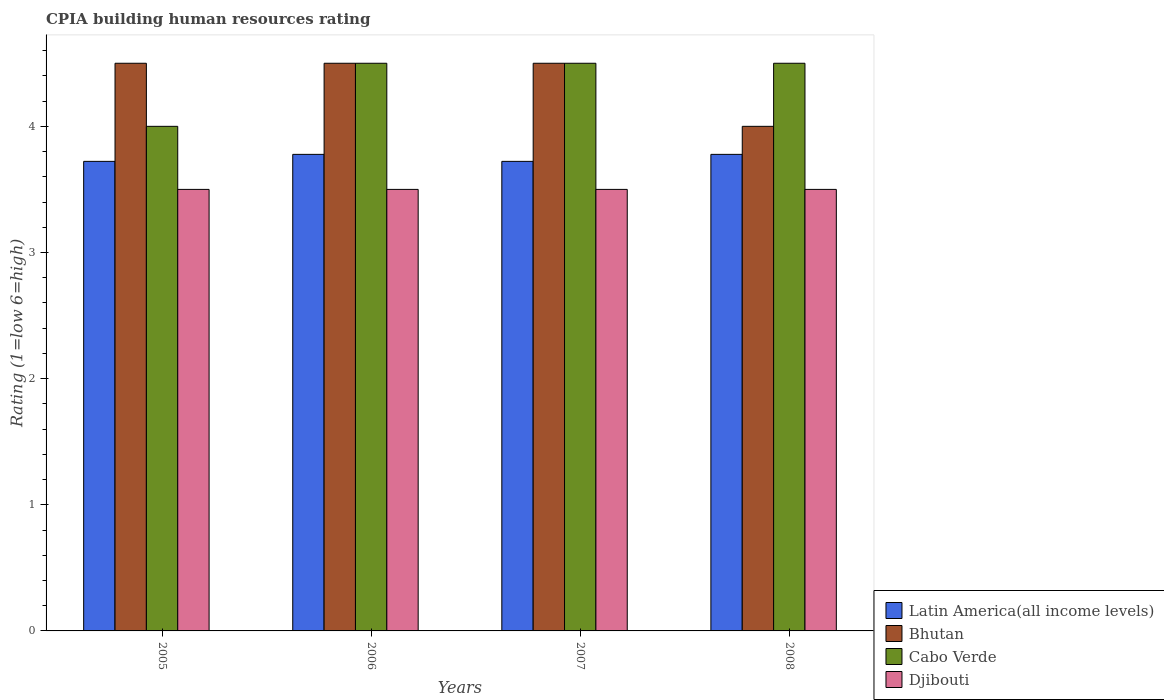Are the number of bars per tick equal to the number of legend labels?
Ensure brevity in your answer.  Yes. Are the number of bars on each tick of the X-axis equal?
Your answer should be very brief. Yes. How many bars are there on the 1st tick from the left?
Give a very brief answer. 4. How many bars are there on the 1st tick from the right?
Keep it short and to the point. 4. What is the label of the 4th group of bars from the left?
Offer a terse response. 2008. What is the CPIA rating in Latin America(all income levels) in 2007?
Ensure brevity in your answer.  3.72. Across all years, what is the maximum CPIA rating in Bhutan?
Keep it short and to the point. 4.5. Across all years, what is the minimum CPIA rating in Latin America(all income levels)?
Offer a terse response. 3.72. In which year was the CPIA rating in Bhutan maximum?
Ensure brevity in your answer.  2005. In which year was the CPIA rating in Cabo Verde minimum?
Offer a terse response. 2005. What is the total CPIA rating in Djibouti in the graph?
Provide a succinct answer. 14. In the year 2005, what is the difference between the CPIA rating in Latin America(all income levels) and CPIA rating in Cabo Verde?
Offer a terse response. -0.28. In how many years, is the CPIA rating in Latin America(all income levels) greater than 0.8?
Your response must be concise. 4. What is the ratio of the CPIA rating in Djibouti in 2006 to that in 2008?
Your answer should be very brief. 1. Is the CPIA rating in Djibouti in 2006 less than that in 2007?
Provide a short and direct response. No. Is the difference between the CPIA rating in Latin America(all income levels) in 2005 and 2006 greater than the difference between the CPIA rating in Cabo Verde in 2005 and 2006?
Ensure brevity in your answer.  Yes. What is the difference between the highest and the second highest CPIA rating in Bhutan?
Make the answer very short. 0. What is the difference between the highest and the lowest CPIA rating in Latin America(all income levels)?
Make the answer very short. 0.06. What does the 4th bar from the left in 2007 represents?
Give a very brief answer. Djibouti. What does the 4th bar from the right in 2008 represents?
Offer a terse response. Latin America(all income levels). Are all the bars in the graph horizontal?
Keep it short and to the point. No. Does the graph contain any zero values?
Give a very brief answer. No. How many legend labels are there?
Provide a succinct answer. 4. What is the title of the graph?
Keep it short and to the point. CPIA building human resources rating. Does "Italy" appear as one of the legend labels in the graph?
Give a very brief answer. No. What is the label or title of the X-axis?
Your answer should be compact. Years. What is the label or title of the Y-axis?
Keep it short and to the point. Rating (1=low 6=high). What is the Rating (1=low 6=high) of Latin America(all income levels) in 2005?
Your answer should be very brief. 3.72. What is the Rating (1=low 6=high) in Cabo Verde in 2005?
Your response must be concise. 4. What is the Rating (1=low 6=high) of Djibouti in 2005?
Your answer should be compact. 3.5. What is the Rating (1=low 6=high) of Latin America(all income levels) in 2006?
Provide a succinct answer. 3.78. What is the Rating (1=low 6=high) of Bhutan in 2006?
Keep it short and to the point. 4.5. What is the Rating (1=low 6=high) of Djibouti in 2006?
Offer a terse response. 3.5. What is the Rating (1=low 6=high) in Latin America(all income levels) in 2007?
Ensure brevity in your answer.  3.72. What is the Rating (1=low 6=high) of Cabo Verde in 2007?
Your answer should be compact. 4.5. What is the Rating (1=low 6=high) of Djibouti in 2007?
Keep it short and to the point. 3.5. What is the Rating (1=low 6=high) in Latin America(all income levels) in 2008?
Give a very brief answer. 3.78. What is the Rating (1=low 6=high) of Bhutan in 2008?
Keep it short and to the point. 4. What is the Rating (1=low 6=high) in Djibouti in 2008?
Ensure brevity in your answer.  3.5. Across all years, what is the maximum Rating (1=low 6=high) of Latin America(all income levels)?
Your answer should be very brief. 3.78. Across all years, what is the maximum Rating (1=low 6=high) in Djibouti?
Offer a very short reply. 3.5. Across all years, what is the minimum Rating (1=low 6=high) of Latin America(all income levels)?
Make the answer very short. 3.72. Across all years, what is the minimum Rating (1=low 6=high) in Bhutan?
Provide a short and direct response. 4. Across all years, what is the minimum Rating (1=low 6=high) of Cabo Verde?
Give a very brief answer. 4. Across all years, what is the minimum Rating (1=low 6=high) in Djibouti?
Keep it short and to the point. 3.5. What is the total Rating (1=low 6=high) of Latin America(all income levels) in the graph?
Give a very brief answer. 15. What is the total Rating (1=low 6=high) of Cabo Verde in the graph?
Offer a terse response. 17.5. What is the total Rating (1=low 6=high) of Djibouti in the graph?
Keep it short and to the point. 14. What is the difference between the Rating (1=low 6=high) in Latin America(all income levels) in 2005 and that in 2006?
Your answer should be compact. -0.06. What is the difference between the Rating (1=low 6=high) in Bhutan in 2005 and that in 2006?
Provide a succinct answer. 0. What is the difference between the Rating (1=low 6=high) of Cabo Verde in 2005 and that in 2006?
Give a very brief answer. -0.5. What is the difference between the Rating (1=low 6=high) of Latin America(all income levels) in 2005 and that in 2007?
Ensure brevity in your answer.  0. What is the difference between the Rating (1=low 6=high) of Bhutan in 2005 and that in 2007?
Offer a very short reply. 0. What is the difference between the Rating (1=low 6=high) in Latin America(all income levels) in 2005 and that in 2008?
Your answer should be very brief. -0.06. What is the difference between the Rating (1=low 6=high) of Bhutan in 2005 and that in 2008?
Ensure brevity in your answer.  0.5. What is the difference between the Rating (1=low 6=high) of Cabo Verde in 2005 and that in 2008?
Keep it short and to the point. -0.5. What is the difference between the Rating (1=low 6=high) in Djibouti in 2005 and that in 2008?
Your answer should be compact. 0. What is the difference between the Rating (1=low 6=high) in Latin America(all income levels) in 2006 and that in 2007?
Keep it short and to the point. 0.06. What is the difference between the Rating (1=low 6=high) of Cabo Verde in 2006 and that in 2007?
Provide a succinct answer. 0. What is the difference between the Rating (1=low 6=high) in Djibouti in 2006 and that in 2007?
Provide a succinct answer. 0. What is the difference between the Rating (1=low 6=high) of Latin America(all income levels) in 2006 and that in 2008?
Ensure brevity in your answer.  0. What is the difference between the Rating (1=low 6=high) in Bhutan in 2006 and that in 2008?
Offer a very short reply. 0.5. What is the difference between the Rating (1=low 6=high) in Djibouti in 2006 and that in 2008?
Provide a succinct answer. 0. What is the difference between the Rating (1=low 6=high) of Latin America(all income levels) in 2007 and that in 2008?
Offer a very short reply. -0.06. What is the difference between the Rating (1=low 6=high) in Bhutan in 2007 and that in 2008?
Your answer should be compact. 0.5. What is the difference between the Rating (1=low 6=high) of Cabo Verde in 2007 and that in 2008?
Provide a succinct answer. 0. What is the difference between the Rating (1=low 6=high) in Djibouti in 2007 and that in 2008?
Ensure brevity in your answer.  0. What is the difference between the Rating (1=low 6=high) in Latin America(all income levels) in 2005 and the Rating (1=low 6=high) in Bhutan in 2006?
Offer a terse response. -0.78. What is the difference between the Rating (1=low 6=high) of Latin America(all income levels) in 2005 and the Rating (1=low 6=high) of Cabo Verde in 2006?
Offer a very short reply. -0.78. What is the difference between the Rating (1=low 6=high) of Latin America(all income levels) in 2005 and the Rating (1=low 6=high) of Djibouti in 2006?
Your response must be concise. 0.22. What is the difference between the Rating (1=low 6=high) of Latin America(all income levels) in 2005 and the Rating (1=low 6=high) of Bhutan in 2007?
Offer a very short reply. -0.78. What is the difference between the Rating (1=low 6=high) in Latin America(all income levels) in 2005 and the Rating (1=low 6=high) in Cabo Verde in 2007?
Keep it short and to the point. -0.78. What is the difference between the Rating (1=low 6=high) of Latin America(all income levels) in 2005 and the Rating (1=low 6=high) of Djibouti in 2007?
Offer a terse response. 0.22. What is the difference between the Rating (1=low 6=high) in Cabo Verde in 2005 and the Rating (1=low 6=high) in Djibouti in 2007?
Offer a very short reply. 0.5. What is the difference between the Rating (1=low 6=high) of Latin America(all income levels) in 2005 and the Rating (1=low 6=high) of Bhutan in 2008?
Ensure brevity in your answer.  -0.28. What is the difference between the Rating (1=low 6=high) of Latin America(all income levels) in 2005 and the Rating (1=low 6=high) of Cabo Verde in 2008?
Your answer should be compact. -0.78. What is the difference between the Rating (1=low 6=high) in Latin America(all income levels) in 2005 and the Rating (1=low 6=high) in Djibouti in 2008?
Offer a very short reply. 0.22. What is the difference between the Rating (1=low 6=high) in Bhutan in 2005 and the Rating (1=low 6=high) in Cabo Verde in 2008?
Ensure brevity in your answer.  0. What is the difference between the Rating (1=low 6=high) in Cabo Verde in 2005 and the Rating (1=low 6=high) in Djibouti in 2008?
Your answer should be very brief. 0.5. What is the difference between the Rating (1=low 6=high) of Latin America(all income levels) in 2006 and the Rating (1=low 6=high) of Bhutan in 2007?
Provide a succinct answer. -0.72. What is the difference between the Rating (1=low 6=high) of Latin America(all income levels) in 2006 and the Rating (1=low 6=high) of Cabo Verde in 2007?
Keep it short and to the point. -0.72. What is the difference between the Rating (1=low 6=high) of Latin America(all income levels) in 2006 and the Rating (1=low 6=high) of Djibouti in 2007?
Offer a very short reply. 0.28. What is the difference between the Rating (1=low 6=high) in Bhutan in 2006 and the Rating (1=low 6=high) in Cabo Verde in 2007?
Offer a very short reply. 0. What is the difference between the Rating (1=low 6=high) in Bhutan in 2006 and the Rating (1=low 6=high) in Djibouti in 2007?
Keep it short and to the point. 1. What is the difference between the Rating (1=low 6=high) in Latin America(all income levels) in 2006 and the Rating (1=low 6=high) in Bhutan in 2008?
Give a very brief answer. -0.22. What is the difference between the Rating (1=low 6=high) of Latin America(all income levels) in 2006 and the Rating (1=low 6=high) of Cabo Verde in 2008?
Your answer should be compact. -0.72. What is the difference between the Rating (1=low 6=high) of Latin America(all income levels) in 2006 and the Rating (1=low 6=high) of Djibouti in 2008?
Keep it short and to the point. 0.28. What is the difference between the Rating (1=low 6=high) in Bhutan in 2006 and the Rating (1=low 6=high) in Djibouti in 2008?
Provide a short and direct response. 1. What is the difference between the Rating (1=low 6=high) in Cabo Verde in 2006 and the Rating (1=low 6=high) in Djibouti in 2008?
Ensure brevity in your answer.  1. What is the difference between the Rating (1=low 6=high) in Latin America(all income levels) in 2007 and the Rating (1=low 6=high) in Bhutan in 2008?
Offer a very short reply. -0.28. What is the difference between the Rating (1=low 6=high) in Latin America(all income levels) in 2007 and the Rating (1=low 6=high) in Cabo Verde in 2008?
Provide a succinct answer. -0.78. What is the difference between the Rating (1=low 6=high) of Latin America(all income levels) in 2007 and the Rating (1=low 6=high) of Djibouti in 2008?
Ensure brevity in your answer.  0.22. What is the difference between the Rating (1=low 6=high) of Bhutan in 2007 and the Rating (1=low 6=high) of Cabo Verde in 2008?
Offer a terse response. 0. What is the difference between the Rating (1=low 6=high) of Bhutan in 2007 and the Rating (1=low 6=high) of Djibouti in 2008?
Ensure brevity in your answer.  1. What is the difference between the Rating (1=low 6=high) in Cabo Verde in 2007 and the Rating (1=low 6=high) in Djibouti in 2008?
Make the answer very short. 1. What is the average Rating (1=low 6=high) of Latin America(all income levels) per year?
Provide a short and direct response. 3.75. What is the average Rating (1=low 6=high) in Bhutan per year?
Keep it short and to the point. 4.38. What is the average Rating (1=low 6=high) of Cabo Verde per year?
Your response must be concise. 4.38. What is the average Rating (1=low 6=high) in Djibouti per year?
Provide a succinct answer. 3.5. In the year 2005, what is the difference between the Rating (1=low 6=high) of Latin America(all income levels) and Rating (1=low 6=high) of Bhutan?
Your answer should be compact. -0.78. In the year 2005, what is the difference between the Rating (1=low 6=high) of Latin America(all income levels) and Rating (1=low 6=high) of Cabo Verde?
Provide a short and direct response. -0.28. In the year 2005, what is the difference between the Rating (1=low 6=high) of Latin America(all income levels) and Rating (1=low 6=high) of Djibouti?
Your answer should be compact. 0.22. In the year 2006, what is the difference between the Rating (1=low 6=high) in Latin America(all income levels) and Rating (1=low 6=high) in Bhutan?
Your answer should be compact. -0.72. In the year 2006, what is the difference between the Rating (1=low 6=high) in Latin America(all income levels) and Rating (1=low 6=high) in Cabo Verde?
Ensure brevity in your answer.  -0.72. In the year 2006, what is the difference between the Rating (1=low 6=high) of Latin America(all income levels) and Rating (1=low 6=high) of Djibouti?
Ensure brevity in your answer.  0.28. In the year 2006, what is the difference between the Rating (1=low 6=high) of Bhutan and Rating (1=low 6=high) of Djibouti?
Offer a very short reply. 1. In the year 2007, what is the difference between the Rating (1=low 6=high) of Latin America(all income levels) and Rating (1=low 6=high) of Bhutan?
Provide a short and direct response. -0.78. In the year 2007, what is the difference between the Rating (1=low 6=high) of Latin America(all income levels) and Rating (1=low 6=high) of Cabo Verde?
Give a very brief answer. -0.78. In the year 2007, what is the difference between the Rating (1=low 6=high) in Latin America(all income levels) and Rating (1=low 6=high) in Djibouti?
Offer a terse response. 0.22. In the year 2007, what is the difference between the Rating (1=low 6=high) of Bhutan and Rating (1=low 6=high) of Cabo Verde?
Keep it short and to the point. 0. In the year 2007, what is the difference between the Rating (1=low 6=high) in Bhutan and Rating (1=low 6=high) in Djibouti?
Your answer should be very brief. 1. In the year 2008, what is the difference between the Rating (1=low 6=high) in Latin America(all income levels) and Rating (1=low 6=high) in Bhutan?
Give a very brief answer. -0.22. In the year 2008, what is the difference between the Rating (1=low 6=high) in Latin America(all income levels) and Rating (1=low 6=high) in Cabo Verde?
Your response must be concise. -0.72. In the year 2008, what is the difference between the Rating (1=low 6=high) in Latin America(all income levels) and Rating (1=low 6=high) in Djibouti?
Keep it short and to the point. 0.28. In the year 2008, what is the difference between the Rating (1=low 6=high) of Bhutan and Rating (1=low 6=high) of Cabo Verde?
Your answer should be very brief. -0.5. In the year 2008, what is the difference between the Rating (1=low 6=high) in Bhutan and Rating (1=low 6=high) in Djibouti?
Keep it short and to the point. 0.5. In the year 2008, what is the difference between the Rating (1=low 6=high) in Cabo Verde and Rating (1=low 6=high) in Djibouti?
Give a very brief answer. 1. What is the ratio of the Rating (1=low 6=high) of Latin America(all income levels) in 2005 to that in 2006?
Give a very brief answer. 0.99. What is the ratio of the Rating (1=low 6=high) in Djibouti in 2005 to that in 2006?
Keep it short and to the point. 1. What is the ratio of the Rating (1=low 6=high) of Bhutan in 2005 to that in 2007?
Offer a terse response. 1. What is the ratio of the Rating (1=low 6=high) of Cabo Verde in 2005 to that in 2007?
Give a very brief answer. 0.89. What is the ratio of the Rating (1=low 6=high) in Latin America(all income levels) in 2005 to that in 2008?
Your answer should be compact. 0.99. What is the ratio of the Rating (1=low 6=high) in Cabo Verde in 2005 to that in 2008?
Offer a very short reply. 0.89. What is the ratio of the Rating (1=low 6=high) of Latin America(all income levels) in 2006 to that in 2007?
Your answer should be compact. 1.01. What is the ratio of the Rating (1=low 6=high) in Latin America(all income levels) in 2006 to that in 2008?
Your answer should be very brief. 1. What is the ratio of the Rating (1=low 6=high) of Bhutan in 2006 to that in 2008?
Your answer should be very brief. 1.12. What is the ratio of the Rating (1=low 6=high) in Cabo Verde in 2006 to that in 2008?
Offer a very short reply. 1. What is the ratio of the Rating (1=low 6=high) of Djibouti in 2006 to that in 2008?
Your answer should be compact. 1. What is the ratio of the Rating (1=low 6=high) in Cabo Verde in 2007 to that in 2008?
Ensure brevity in your answer.  1. What is the difference between the highest and the second highest Rating (1=low 6=high) in Bhutan?
Offer a terse response. 0. What is the difference between the highest and the second highest Rating (1=low 6=high) of Cabo Verde?
Make the answer very short. 0. What is the difference between the highest and the second highest Rating (1=low 6=high) in Djibouti?
Offer a terse response. 0. What is the difference between the highest and the lowest Rating (1=low 6=high) of Latin America(all income levels)?
Provide a succinct answer. 0.06. What is the difference between the highest and the lowest Rating (1=low 6=high) of Bhutan?
Provide a short and direct response. 0.5. What is the difference between the highest and the lowest Rating (1=low 6=high) of Djibouti?
Make the answer very short. 0. 